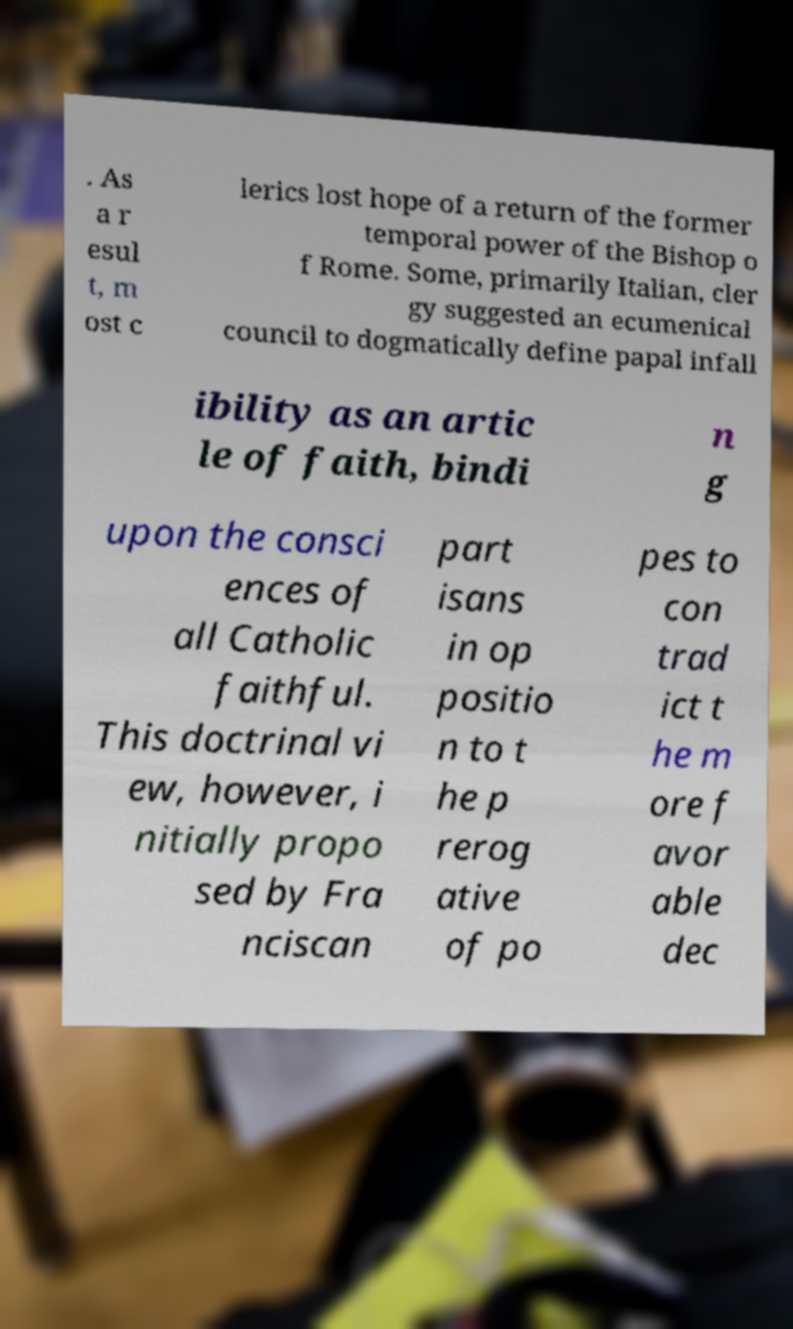What messages or text are displayed in this image? I need them in a readable, typed format. . As a r esul t, m ost c lerics lost hope of a return of the former temporal power of the Bishop o f Rome. Some, primarily Italian, cler gy suggested an ecumenical council to dogmatically define papal infall ibility as an artic le of faith, bindi n g upon the consci ences of all Catholic faithful. This doctrinal vi ew, however, i nitially propo sed by Fra nciscan part isans in op positio n to t he p rerog ative of po pes to con trad ict t he m ore f avor able dec 